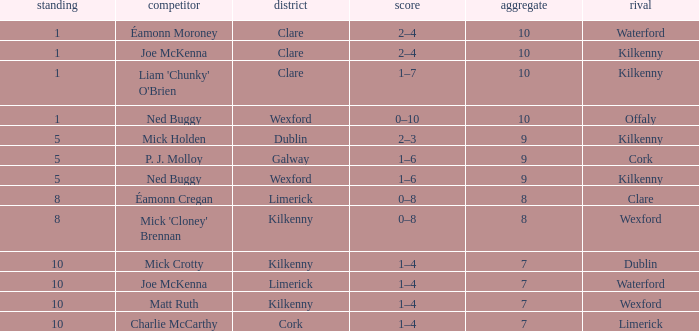Which Total has a County of kilkenny, and a Tally of 1–4, and a Rank larger than 10? None. Parse the full table. {'header': ['standing', 'competitor', 'district', 'score', 'aggregate', 'rival'], 'rows': [['1', 'Éamonn Moroney', 'Clare', '2–4', '10', 'Waterford'], ['1', 'Joe McKenna', 'Clare', '2–4', '10', 'Kilkenny'], ['1', "Liam 'Chunky' O'Brien", 'Clare', '1–7', '10', 'Kilkenny'], ['1', 'Ned Buggy', 'Wexford', '0–10', '10', 'Offaly'], ['5', 'Mick Holden', 'Dublin', '2–3', '9', 'Kilkenny'], ['5', 'P. J. Molloy', 'Galway', '1–6', '9', 'Cork'], ['5', 'Ned Buggy', 'Wexford', '1–6', '9', 'Kilkenny'], ['8', 'Éamonn Cregan', 'Limerick', '0–8', '8', 'Clare'], ['8', "Mick 'Cloney' Brennan", 'Kilkenny', '0–8', '8', 'Wexford'], ['10', 'Mick Crotty', 'Kilkenny', '1–4', '7', 'Dublin'], ['10', 'Joe McKenna', 'Limerick', '1–4', '7', 'Waterford'], ['10', 'Matt Ruth', 'Kilkenny', '1–4', '7', 'Wexford'], ['10', 'Charlie McCarthy', 'Cork', '1–4', '7', 'Limerick']]} 